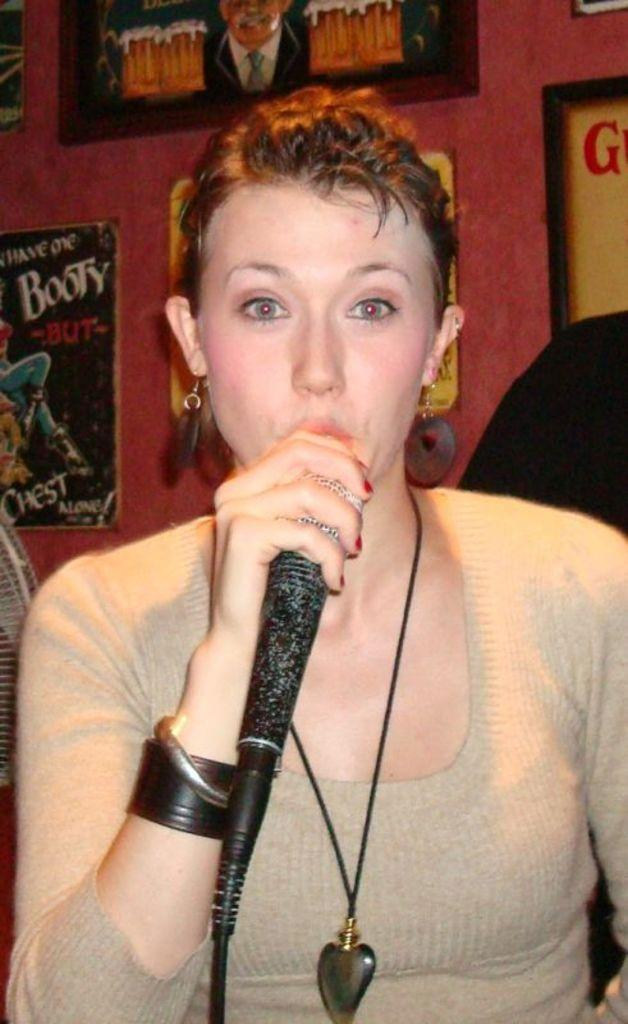Who is the main subject in the image? There is a lady in the image. What is the lady wearing? The lady is wearing a grey t-shirt. What is the lady holding in her right hand? The lady is holding a mic in her right hand. What can be seen on the wall behind the lady? There are frames and posters on the wall behind her. How does the lady tie a knot with the mic in the image? The lady is not tying a knot with the mic in the image; she is simply holding it in her hand. 